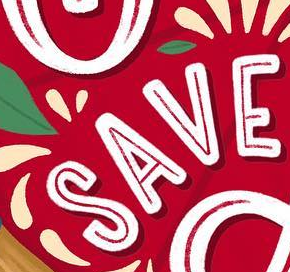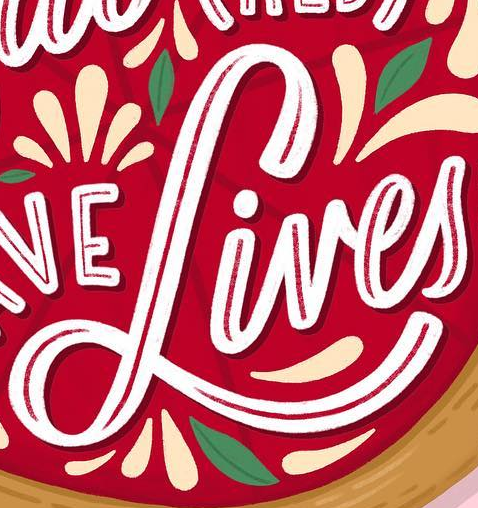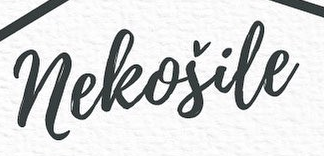Identify the words shown in these images in order, separated by a semicolon. SAVE; Lives; neleošile 